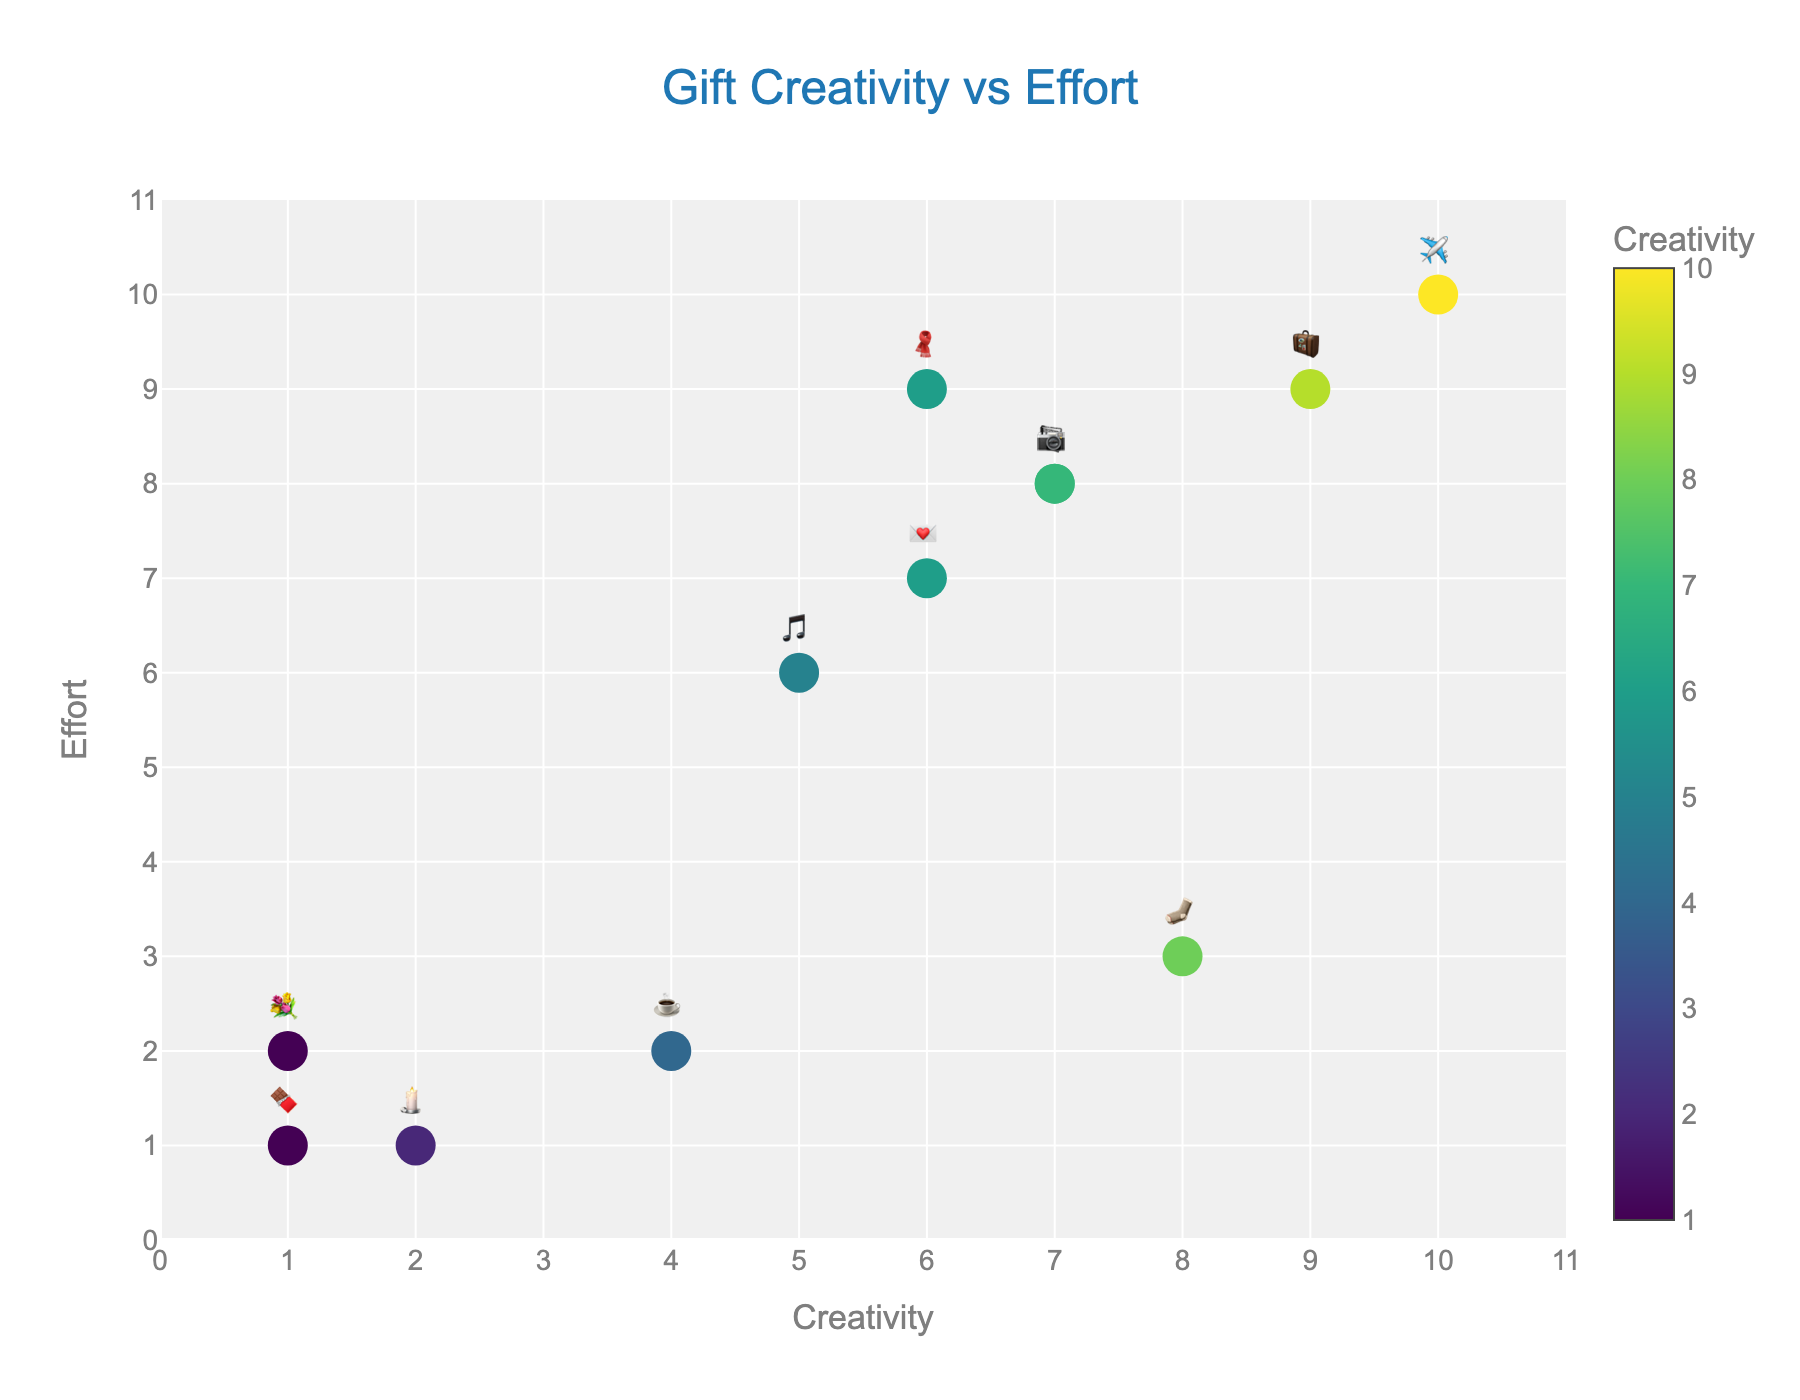What's the title of the figure? The title is usually found at the top of the figure. In this case, it's centered and highlighted in a larger font.
Answer: "Gift Creativity vs Effort" What's the range of values on the y-axis? The y-axis represents Effort, and it ranges from 0 to 11 with tick marks at each integer value.
Answer: 0 to 11 How many gift types have a creativity score greater than 6? To answer this, count the number of data points with Creativity values higher than 6.
Answer: 6 Which gift requires the highest effort? The highest effort value is 10, which corresponds to the skywriting marriage proposal emoji. You can confirm this by looking at the hovertext or the placement in the upper right.
Answer: Skywriting marriage proposal ✈️ What's the average creativity score for gifts with an effort score of 7? Look at the points where Effort equals 7, which are the handwritten love letter and personalized playlist. Their Creativity scores are 6 and 5. The average is (6 + 5) / 2 = 5.5.
Answer: 5.5 Which gift is represented by the emoji 🧳 and what are its Creativity and Effort scores? Identify the emoji and check its position and hovertext on the plot. The gift is a surprise weekend getaway with scores of 9 for both Creativity and Effort.
Answer: Surprise weekend getaway, Creativity: 9, Effort: 9 Do any gifts have both the lowest creativity and effort scores? The lowest scores for both Creativity and Effort are 1. Check if any data point has these values. The last-minute gas station chocolates fit this description.
Answer: Yes, last-minute gas station chocolates 🍫 Which gift has the most balanced combination of creativity and effort? (i.e., closest to a 45-degree diagonal) The gifts closest to the diagonal line where Creativity equals Effort have scores 9 and 9 (surprise weekend getaway), 6 and 7 (handwritten love letter), etc. The surprise weekend getaway is the most balanced.
Answer: Surprise weekend getaway 🧳 What's the creativity range of gifts that are represented with emojis 🧣 and 📷? Find the creativity scores for these emojis, which are Handmade scarf (🧣) and Custom photo album (📷). These scores are 6 and 7, respectively.
Answer: 6 to 7 